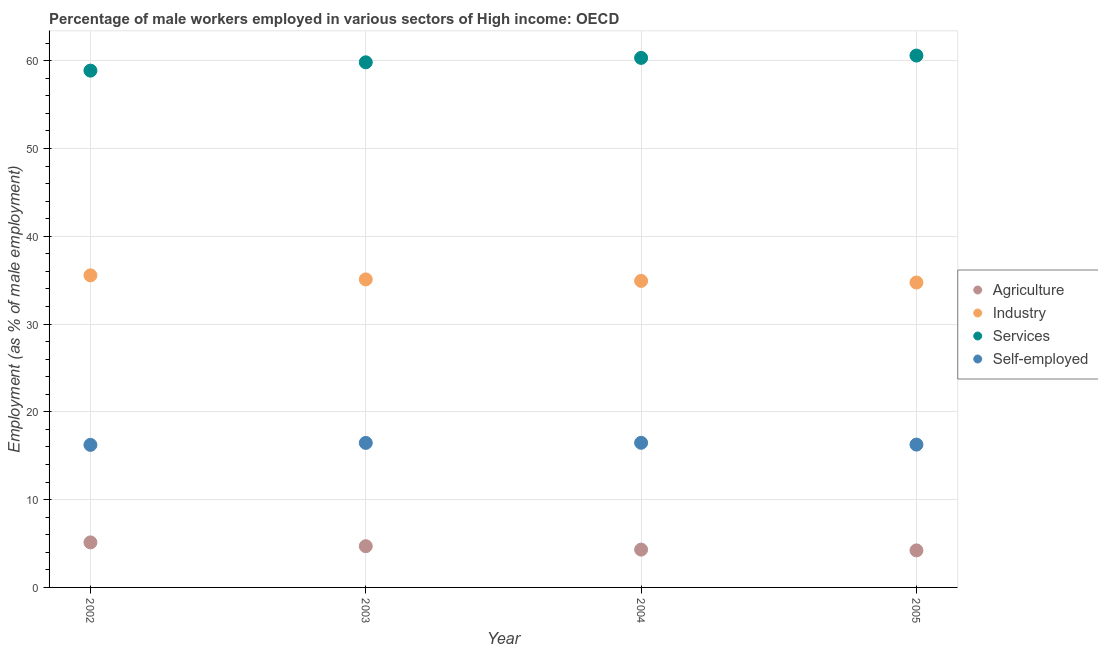How many different coloured dotlines are there?
Your response must be concise. 4. Is the number of dotlines equal to the number of legend labels?
Provide a short and direct response. Yes. What is the percentage of male workers in industry in 2002?
Provide a succinct answer. 35.55. Across all years, what is the maximum percentage of male workers in industry?
Provide a succinct answer. 35.55. Across all years, what is the minimum percentage of self employed male workers?
Your response must be concise. 16.24. In which year was the percentage of self employed male workers maximum?
Keep it short and to the point. 2004. What is the total percentage of male workers in services in the graph?
Make the answer very short. 239.58. What is the difference between the percentage of male workers in industry in 2003 and that in 2004?
Provide a succinct answer. 0.17. What is the difference between the percentage of male workers in agriculture in 2003 and the percentage of male workers in services in 2002?
Make the answer very short. -54.17. What is the average percentage of male workers in services per year?
Your response must be concise. 59.9. In the year 2003, what is the difference between the percentage of male workers in services and percentage of male workers in agriculture?
Ensure brevity in your answer.  55.12. In how many years, is the percentage of self employed male workers greater than 8 %?
Make the answer very short. 4. What is the ratio of the percentage of male workers in agriculture in 2002 to that in 2005?
Provide a succinct answer. 1.22. Is the percentage of male workers in industry in 2002 less than that in 2005?
Offer a terse response. No. What is the difference between the highest and the second highest percentage of male workers in services?
Provide a succinct answer. 0.26. What is the difference between the highest and the lowest percentage of self employed male workers?
Your answer should be very brief. 0.24. Is the sum of the percentage of male workers in services in 2002 and 2004 greater than the maximum percentage of male workers in agriculture across all years?
Your response must be concise. Yes. Is it the case that in every year, the sum of the percentage of male workers in agriculture and percentage of male workers in industry is greater than the percentage of male workers in services?
Offer a very short reply. No. What is the difference between two consecutive major ticks on the Y-axis?
Make the answer very short. 10. Does the graph contain any zero values?
Provide a short and direct response. No. Does the graph contain grids?
Keep it short and to the point. Yes. How many legend labels are there?
Your response must be concise. 4. How are the legend labels stacked?
Ensure brevity in your answer.  Vertical. What is the title of the graph?
Keep it short and to the point. Percentage of male workers employed in various sectors of High income: OECD. What is the label or title of the Y-axis?
Your response must be concise. Employment (as % of male employment). What is the Employment (as % of male employment) of Agriculture in 2002?
Your answer should be very brief. 5.13. What is the Employment (as % of male employment) of Industry in 2002?
Your answer should be compact. 35.55. What is the Employment (as % of male employment) in Services in 2002?
Keep it short and to the point. 58.87. What is the Employment (as % of male employment) of Self-employed in 2002?
Your answer should be compact. 16.24. What is the Employment (as % of male employment) in Agriculture in 2003?
Offer a terse response. 4.7. What is the Employment (as % of male employment) in Industry in 2003?
Offer a terse response. 35.09. What is the Employment (as % of male employment) in Services in 2003?
Offer a very short reply. 59.81. What is the Employment (as % of male employment) in Self-employed in 2003?
Provide a succinct answer. 16.46. What is the Employment (as % of male employment) of Agriculture in 2004?
Offer a terse response. 4.31. What is the Employment (as % of male employment) of Industry in 2004?
Keep it short and to the point. 34.92. What is the Employment (as % of male employment) of Services in 2004?
Your answer should be compact. 60.32. What is the Employment (as % of male employment) of Self-employed in 2004?
Ensure brevity in your answer.  16.48. What is the Employment (as % of male employment) of Agriculture in 2005?
Provide a succinct answer. 4.22. What is the Employment (as % of male employment) in Industry in 2005?
Your response must be concise. 34.73. What is the Employment (as % of male employment) of Services in 2005?
Make the answer very short. 60.58. What is the Employment (as % of male employment) in Self-employed in 2005?
Provide a short and direct response. 16.27. Across all years, what is the maximum Employment (as % of male employment) in Agriculture?
Your response must be concise. 5.13. Across all years, what is the maximum Employment (as % of male employment) of Industry?
Provide a succinct answer. 35.55. Across all years, what is the maximum Employment (as % of male employment) of Services?
Ensure brevity in your answer.  60.58. Across all years, what is the maximum Employment (as % of male employment) in Self-employed?
Your answer should be very brief. 16.48. Across all years, what is the minimum Employment (as % of male employment) in Agriculture?
Make the answer very short. 4.22. Across all years, what is the minimum Employment (as % of male employment) of Industry?
Keep it short and to the point. 34.73. Across all years, what is the minimum Employment (as % of male employment) in Services?
Ensure brevity in your answer.  58.87. Across all years, what is the minimum Employment (as % of male employment) of Self-employed?
Make the answer very short. 16.24. What is the total Employment (as % of male employment) of Agriculture in the graph?
Provide a short and direct response. 18.35. What is the total Employment (as % of male employment) in Industry in the graph?
Offer a terse response. 140.29. What is the total Employment (as % of male employment) in Services in the graph?
Offer a very short reply. 239.58. What is the total Employment (as % of male employment) of Self-employed in the graph?
Your response must be concise. 65.44. What is the difference between the Employment (as % of male employment) in Agriculture in 2002 and that in 2003?
Make the answer very short. 0.43. What is the difference between the Employment (as % of male employment) in Industry in 2002 and that in 2003?
Keep it short and to the point. 0.46. What is the difference between the Employment (as % of male employment) of Services in 2002 and that in 2003?
Offer a very short reply. -0.95. What is the difference between the Employment (as % of male employment) of Self-employed in 2002 and that in 2003?
Your response must be concise. -0.22. What is the difference between the Employment (as % of male employment) in Agriculture in 2002 and that in 2004?
Keep it short and to the point. 0.82. What is the difference between the Employment (as % of male employment) of Industry in 2002 and that in 2004?
Your response must be concise. 0.63. What is the difference between the Employment (as % of male employment) in Services in 2002 and that in 2004?
Your response must be concise. -1.45. What is the difference between the Employment (as % of male employment) of Self-employed in 2002 and that in 2004?
Ensure brevity in your answer.  -0.24. What is the difference between the Employment (as % of male employment) in Agriculture in 2002 and that in 2005?
Ensure brevity in your answer.  0.91. What is the difference between the Employment (as % of male employment) of Industry in 2002 and that in 2005?
Your response must be concise. 0.82. What is the difference between the Employment (as % of male employment) of Services in 2002 and that in 2005?
Provide a short and direct response. -1.72. What is the difference between the Employment (as % of male employment) of Self-employed in 2002 and that in 2005?
Provide a short and direct response. -0.03. What is the difference between the Employment (as % of male employment) in Agriculture in 2003 and that in 2004?
Give a very brief answer. 0.39. What is the difference between the Employment (as % of male employment) in Industry in 2003 and that in 2004?
Keep it short and to the point. 0.17. What is the difference between the Employment (as % of male employment) of Services in 2003 and that in 2004?
Your answer should be very brief. -0.5. What is the difference between the Employment (as % of male employment) of Self-employed in 2003 and that in 2004?
Offer a terse response. -0.01. What is the difference between the Employment (as % of male employment) in Agriculture in 2003 and that in 2005?
Offer a very short reply. 0.48. What is the difference between the Employment (as % of male employment) in Industry in 2003 and that in 2005?
Your answer should be compact. 0.36. What is the difference between the Employment (as % of male employment) in Services in 2003 and that in 2005?
Ensure brevity in your answer.  -0.77. What is the difference between the Employment (as % of male employment) of Self-employed in 2003 and that in 2005?
Your answer should be compact. 0.19. What is the difference between the Employment (as % of male employment) of Agriculture in 2004 and that in 2005?
Your answer should be compact. 0.09. What is the difference between the Employment (as % of male employment) in Industry in 2004 and that in 2005?
Your response must be concise. 0.19. What is the difference between the Employment (as % of male employment) in Services in 2004 and that in 2005?
Your answer should be very brief. -0.26. What is the difference between the Employment (as % of male employment) in Self-employed in 2004 and that in 2005?
Offer a terse response. 0.21. What is the difference between the Employment (as % of male employment) in Agriculture in 2002 and the Employment (as % of male employment) in Industry in 2003?
Your answer should be very brief. -29.96. What is the difference between the Employment (as % of male employment) of Agriculture in 2002 and the Employment (as % of male employment) of Services in 2003?
Ensure brevity in your answer.  -54.69. What is the difference between the Employment (as % of male employment) in Agriculture in 2002 and the Employment (as % of male employment) in Self-employed in 2003?
Give a very brief answer. -11.33. What is the difference between the Employment (as % of male employment) in Industry in 2002 and the Employment (as % of male employment) in Services in 2003?
Provide a succinct answer. -24.27. What is the difference between the Employment (as % of male employment) in Industry in 2002 and the Employment (as % of male employment) in Self-employed in 2003?
Your answer should be very brief. 19.09. What is the difference between the Employment (as % of male employment) in Services in 2002 and the Employment (as % of male employment) in Self-employed in 2003?
Provide a succinct answer. 42.41. What is the difference between the Employment (as % of male employment) of Agriculture in 2002 and the Employment (as % of male employment) of Industry in 2004?
Offer a terse response. -29.79. What is the difference between the Employment (as % of male employment) of Agriculture in 2002 and the Employment (as % of male employment) of Services in 2004?
Provide a short and direct response. -55.19. What is the difference between the Employment (as % of male employment) of Agriculture in 2002 and the Employment (as % of male employment) of Self-employed in 2004?
Give a very brief answer. -11.35. What is the difference between the Employment (as % of male employment) in Industry in 2002 and the Employment (as % of male employment) in Services in 2004?
Your answer should be very brief. -24.77. What is the difference between the Employment (as % of male employment) of Industry in 2002 and the Employment (as % of male employment) of Self-employed in 2004?
Your answer should be very brief. 19.07. What is the difference between the Employment (as % of male employment) in Services in 2002 and the Employment (as % of male employment) in Self-employed in 2004?
Ensure brevity in your answer.  42.39. What is the difference between the Employment (as % of male employment) of Agriculture in 2002 and the Employment (as % of male employment) of Industry in 2005?
Keep it short and to the point. -29.6. What is the difference between the Employment (as % of male employment) of Agriculture in 2002 and the Employment (as % of male employment) of Services in 2005?
Offer a terse response. -55.45. What is the difference between the Employment (as % of male employment) in Agriculture in 2002 and the Employment (as % of male employment) in Self-employed in 2005?
Offer a terse response. -11.14. What is the difference between the Employment (as % of male employment) in Industry in 2002 and the Employment (as % of male employment) in Services in 2005?
Your answer should be compact. -25.03. What is the difference between the Employment (as % of male employment) of Industry in 2002 and the Employment (as % of male employment) of Self-employed in 2005?
Give a very brief answer. 19.28. What is the difference between the Employment (as % of male employment) of Services in 2002 and the Employment (as % of male employment) of Self-employed in 2005?
Offer a very short reply. 42.6. What is the difference between the Employment (as % of male employment) in Agriculture in 2003 and the Employment (as % of male employment) in Industry in 2004?
Keep it short and to the point. -30.22. What is the difference between the Employment (as % of male employment) in Agriculture in 2003 and the Employment (as % of male employment) in Services in 2004?
Offer a terse response. -55.62. What is the difference between the Employment (as % of male employment) in Agriculture in 2003 and the Employment (as % of male employment) in Self-employed in 2004?
Give a very brief answer. -11.78. What is the difference between the Employment (as % of male employment) of Industry in 2003 and the Employment (as % of male employment) of Services in 2004?
Offer a terse response. -25.23. What is the difference between the Employment (as % of male employment) of Industry in 2003 and the Employment (as % of male employment) of Self-employed in 2004?
Keep it short and to the point. 18.61. What is the difference between the Employment (as % of male employment) in Services in 2003 and the Employment (as % of male employment) in Self-employed in 2004?
Offer a very short reply. 43.34. What is the difference between the Employment (as % of male employment) in Agriculture in 2003 and the Employment (as % of male employment) in Industry in 2005?
Give a very brief answer. -30.04. What is the difference between the Employment (as % of male employment) of Agriculture in 2003 and the Employment (as % of male employment) of Services in 2005?
Give a very brief answer. -55.89. What is the difference between the Employment (as % of male employment) of Agriculture in 2003 and the Employment (as % of male employment) of Self-employed in 2005?
Provide a succinct answer. -11.57. What is the difference between the Employment (as % of male employment) in Industry in 2003 and the Employment (as % of male employment) in Services in 2005?
Give a very brief answer. -25.49. What is the difference between the Employment (as % of male employment) of Industry in 2003 and the Employment (as % of male employment) of Self-employed in 2005?
Provide a succinct answer. 18.82. What is the difference between the Employment (as % of male employment) of Services in 2003 and the Employment (as % of male employment) of Self-employed in 2005?
Provide a short and direct response. 43.55. What is the difference between the Employment (as % of male employment) of Agriculture in 2004 and the Employment (as % of male employment) of Industry in 2005?
Your answer should be compact. -30.42. What is the difference between the Employment (as % of male employment) in Agriculture in 2004 and the Employment (as % of male employment) in Services in 2005?
Your response must be concise. -56.27. What is the difference between the Employment (as % of male employment) of Agriculture in 2004 and the Employment (as % of male employment) of Self-employed in 2005?
Offer a terse response. -11.96. What is the difference between the Employment (as % of male employment) of Industry in 2004 and the Employment (as % of male employment) of Services in 2005?
Your response must be concise. -25.67. What is the difference between the Employment (as % of male employment) in Industry in 2004 and the Employment (as % of male employment) in Self-employed in 2005?
Your response must be concise. 18.65. What is the difference between the Employment (as % of male employment) in Services in 2004 and the Employment (as % of male employment) in Self-employed in 2005?
Keep it short and to the point. 44.05. What is the average Employment (as % of male employment) in Agriculture per year?
Offer a terse response. 4.59. What is the average Employment (as % of male employment) in Industry per year?
Provide a succinct answer. 35.07. What is the average Employment (as % of male employment) in Services per year?
Keep it short and to the point. 59.9. What is the average Employment (as % of male employment) of Self-employed per year?
Ensure brevity in your answer.  16.36. In the year 2002, what is the difference between the Employment (as % of male employment) of Agriculture and Employment (as % of male employment) of Industry?
Give a very brief answer. -30.42. In the year 2002, what is the difference between the Employment (as % of male employment) of Agriculture and Employment (as % of male employment) of Services?
Offer a terse response. -53.74. In the year 2002, what is the difference between the Employment (as % of male employment) in Agriculture and Employment (as % of male employment) in Self-employed?
Keep it short and to the point. -11.11. In the year 2002, what is the difference between the Employment (as % of male employment) in Industry and Employment (as % of male employment) in Services?
Your answer should be very brief. -23.32. In the year 2002, what is the difference between the Employment (as % of male employment) in Industry and Employment (as % of male employment) in Self-employed?
Offer a very short reply. 19.31. In the year 2002, what is the difference between the Employment (as % of male employment) of Services and Employment (as % of male employment) of Self-employed?
Provide a succinct answer. 42.63. In the year 2003, what is the difference between the Employment (as % of male employment) of Agriculture and Employment (as % of male employment) of Industry?
Provide a succinct answer. -30.39. In the year 2003, what is the difference between the Employment (as % of male employment) in Agriculture and Employment (as % of male employment) in Services?
Give a very brief answer. -55.12. In the year 2003, what is the difference between the Employment (as % of male employment) of Agriculture and Employment (as % of male employment) of Self-employed?
Keep it short and to the point. -11.77. In the year 2003, what is the difference between the Employment (as % of male employment) in Industry and Employment (as % of male employment) in Services?
Ensure brevity in your answer.  -24.73. In the year 2003, what is the difference between the Employment (as % of male employment) of Industry and Employment (as % of male employment) of Self-employed?
Offer a very short reply. 18.63. In the year 2003, what is the difference between the Employment (as % of male employment) in Services and Employment (as % of male employment) in Self-employed?
Your answer should be compact. 43.35. In the year 2004, what is the difference between the Employment (as % of male employment) in Agriculture and Employment (as % of male employment) in Industry?
Make the answer very short. -30.61. In the year 2004, what is the difference between the Employment (as % of male employment) of Agriculture and Employment (as % of male employment) of Services?
Ensure brevity in your answer.  -56.01. In the year 2004, what is the difference between the Employment (as % of male employment) of Agriculture and Employment (as % of male employment) of Self-employed?
Your response must be concise. -12.17. In the year 2004, what is the difference between the Employment (as % of male employment) in Industry and Employment (as % of male employment) in Services?
Your answer should be very brief. -25.4. In the year 2004, what is the difference between the Employment (as % of male employment) of Industry and Employment (as % of male employment) of Self-employed?
Make the answer very short. 18.44. In the year 2004, what is the difference between the Employment (as % of male employment) in Services and Employment (as % of male employment) in Self-employed?
Provide a succinct answer. 43.84. In the year 2005, what is the difference between the Employment (as % of male employment) in Agriculture and Employment (as % of male employment) in Industry?
Make the answer very short. -30.51. In the year 2005, what is the difference between the Employment (as % of male employment) of Agriculture and Employment (as % of male employment) of Services?
Provide a short and direct response. -56.37. In the year 2005, what is the difference between the Employment (as % of male employment) of Agriculture and Employment (as % of male employment) of Self-employed?
Your answer should be very brief. -12.05. In the year 2005, what is the difference between the Employment (as % of male employment) in Industry and Employment (as % of male employment) in Services?
Provide a succinct answer. -25.85. In the year 2005, what is the difference between the Employment (as % of male employment) of Industry and Employment (as % of male employment) of Self-employed?
Your response must be concise. 18.46. In the year 2005, what is the difference between the Employment (as % of male employment) of Services and Employment (as % of male employment) of Self-employed?
Give a very brief answer. 44.31. What is the ratio of the Employment (as % of male employment) of Agriculture in 2002 to that in 2003?
Provide a succinct answer. 1.09. What is the ratio of the Employment (as % of male employment) in Industry in 2002 to that in 2003?
Your response must be concise. 1.01. What is the ratio of the Employment (as % of male employment) in Services in 2002 to that in 2003?
Make the answer very short. 0.98. What is the ratio of the Employment (as % of male employment) in Self-employed in 2002 to that in 2003?
Give a very brief answer. 0.99. What is the ratio of the Employment (as % of male employment) of Agriculture in 2002 to that in 2004?
Offer a terse response. 1.19. What is the ratio of the Employment (as % of male employment) in Industry in 2002 to that in 2004?
Your answer should be compact. 1.02. What is the ratio of the Employment (as % of male employment) of Services in 2002 to that in 2004?
Offer a terse response. 0.98. What is the ratio of the Employment (as % of male employment) in Self-employed in 2002 to that in 2004?
Offer a very short reply. 0.99. What is the ratio of the Employment (as % of male employment) of Agriculture in 2002 to that in 2005?
Your answer should be compact. 1.22. What is the ratio of the Employment (as % of male employment) in Industry in 2002 to that in 2005?
Your answer should be very brief. 1.02. What is the ratio of the Employment (as % of male employment) in Services in 2002 to that in 2005?
Your answer should be compact. 0.97. What is the ratio of the Employment (as % of male employment) in Self-employed in 2002 to that in 2005?
Provide a succinct answer. 1. What is the ratio of the Employment (as % of male employment) in Agriculture in 2003 to that in 2004?
Offer a very short reply. 1.09. What is the ratio of the Employment (as % of male employment) of Industry in 2003 to that in 2004?
Your response must be concise. 1. What is the ratio of the Employment (as % of male employment) of Agriculture in 2003 to that in 2005?
Ensure brevity in your answer.  1.11. What is the ratio of the Employment (as % of male employment) in Industry in 2003 to that in 2005?
Give a very brief answer. 1.01. What is the ratio of the Employment (as % of male employment) of Services in 2003 to that in 2005?
Provide a short and direct response. 0.99. What is the ratio of the Employment (as % of male employment) of Self-employed in 2003 to that in 2005?
Ensure brevity in your answer.  1.01. What is the ratio of the Employment (as % of male employment) of Agriculture in 2004 to that in 2005?
Ensure brevity in your answer.  1.02. What is the ratio of the Employment (as % of male employment) in Industry in 2004 to that in 2005?
Provide a short and direct response. 1.01. What is the ratio of the Employment (as % of male employment) in Self-employed in 2004 to that in 2005?
Offer a terse response. 1.01. What is the difference between the highest and the second highest Employment (as % of male employment) of Agriculture?
Your answer should be very brief. 0.43. What is the difference between the highest and the second highest Employment (as % of male employment) in Industry?
Provide a short and direct response. 0.46. What is the difference between the highest and the second highest Employment (as % of male employment) of Services?
Offer a very short reply. 0.26. What is the difference between the highest and the second highest Employment (as % of male employment) of Self-employed?
Provide a succinct answer. 0.01. What is the difference between the highest and the lowest Employment (as % of male employment) in Agriculture?
Your response must be concise. 0.91. What is the difference between the highest and the lowest Employment (as % of male employment) of Industry?
Your answer should be very brief. 0.82. What is the difference between the highest and the lowest Employment (as % of male employment) of Services?
Provide a short and direct response. 1.72. What is the difference between the highest and the lowest Employment (as % of male employment) of Self-employed?
Keep it short and to the point. 0.24. 